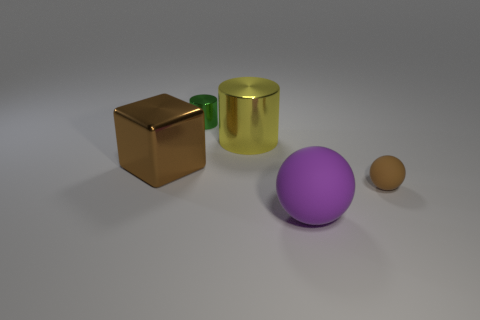Add 1 rubber balls. How many objects exist? 6 Subtract all spheres. How many objects are left? 3 Subtract 0 yellow blocks. How many objects are left? 5 Subtract all big metal cylinders. Subtract all yellow metal objects. How many objects are left? 3 Add 3 brown matte spheres. How many brown matte spheres are left? 4 Add 3 large purple matte balls. How many large purple matte balls exist? 4 